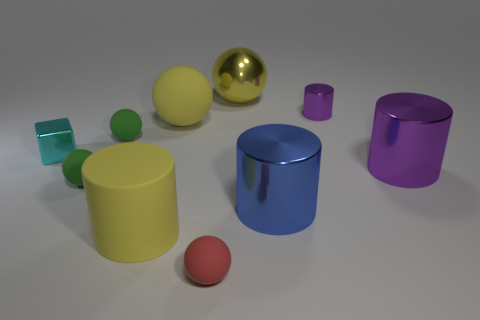Can you tell me how many objects are in the image, and what colors they are? In the image, there are nine objects. The colors present are red, yellow, green, two shades of blue, purple, gold, and teal. The objects appear to be of various geometric shapes, including spheres and cylinders. 